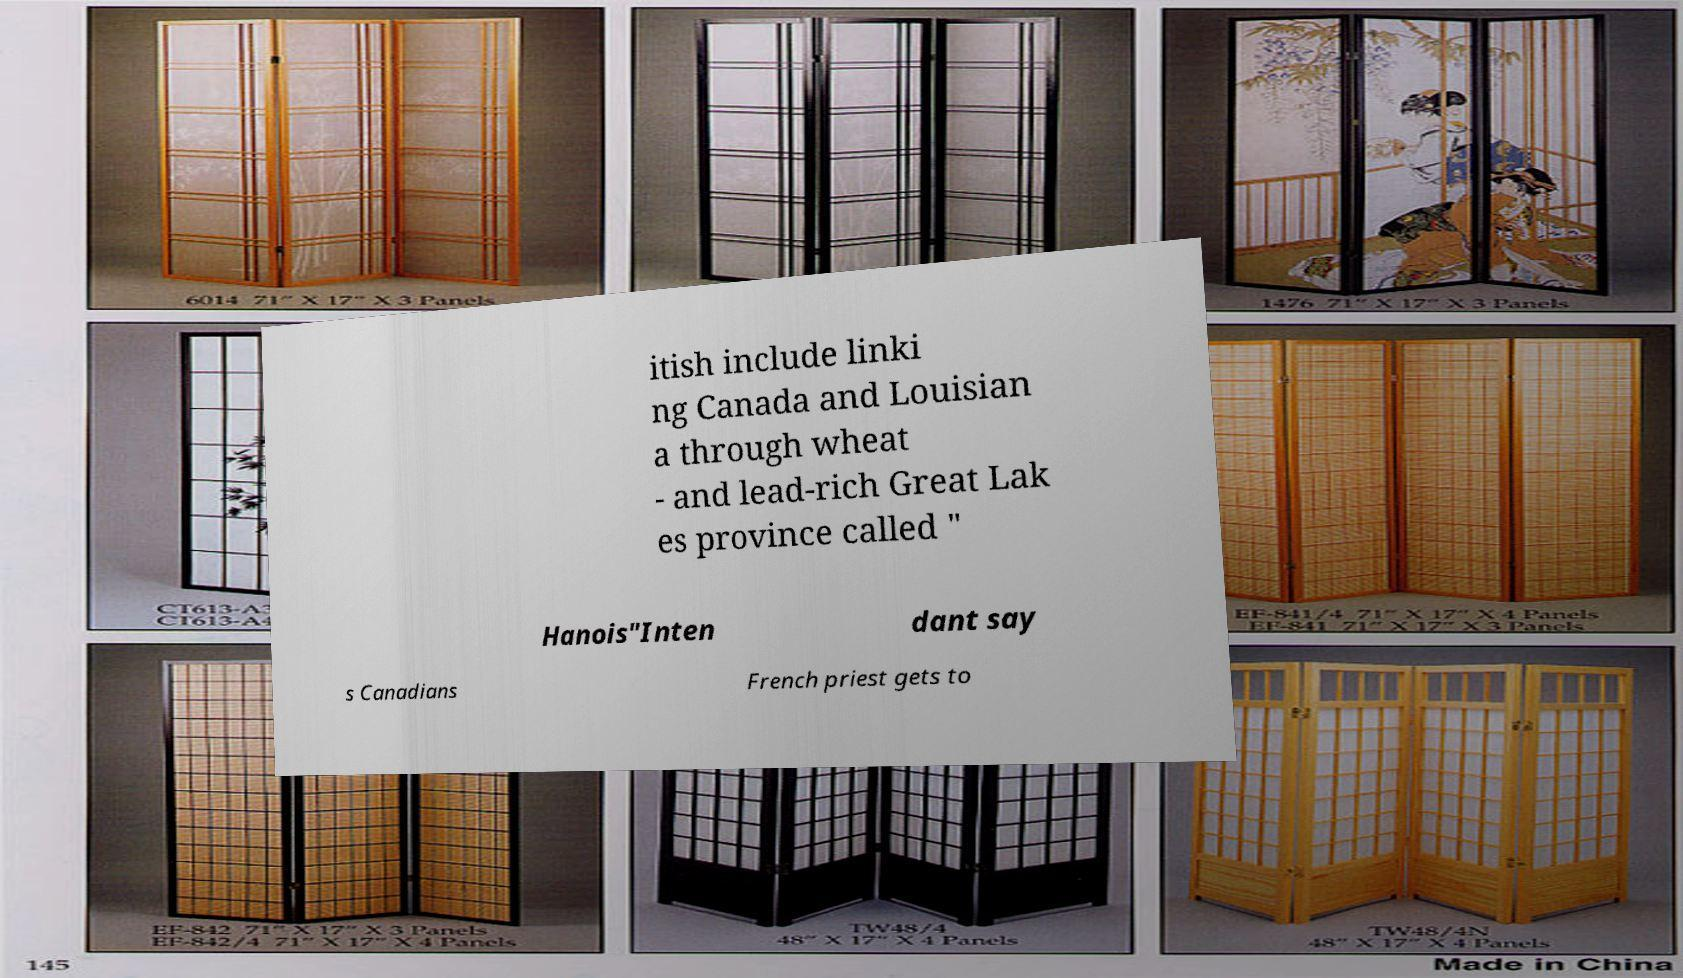There's text embedded in this image that I need extracted. Can you transcribe it verbatim? itish include linki ng Canada and Louisian a through wheat - and lead-rich Great Lak es province called " Hanois"Inten dant say s Canadians French priest gets to 